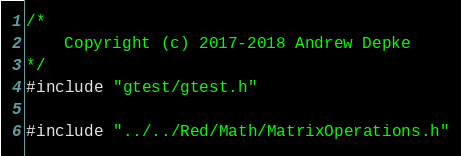Convert code to text. <code><loc_0><loc_0><loc_500><loc_500><_C++_>/*
	Copyright (c) 2017-2018 Andrew Depke
*/
#include "gtest/gtest.h"

#include "../../Red/Math/MatrixOperations.h"</code> 